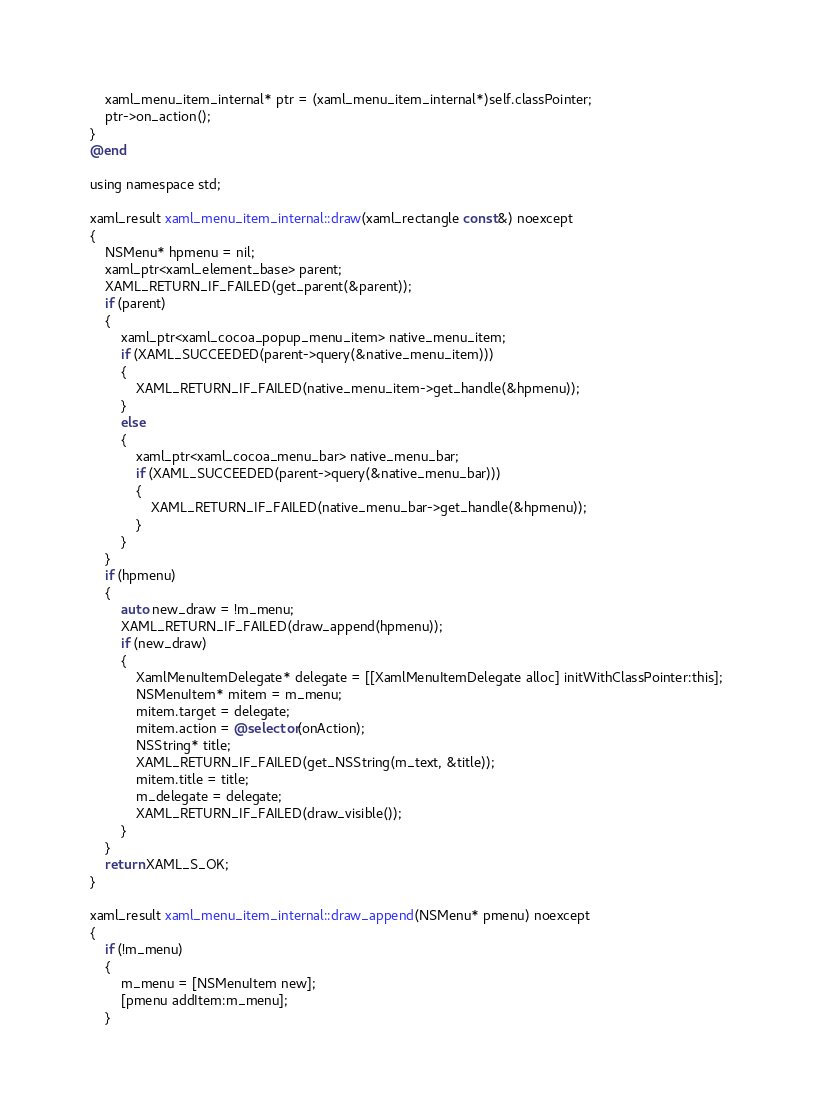Convert code to text. <code><loc_0><loc_0><loc_500><loc_500><_ObjectiveC_>    xaml_menu_item_internal* ptr = (xaml_menu_item_internal*)self.classPointer;
    ptr->on_action();
}
@end

using namespace std;

xaml_result xaml_menu_item_internal::draw(xaml_rectangle const&) noexcept
{
    NSMenu* hpmenu = nil;
    xaml_ptr<xaml_element_base> parent;
    XAML_RETURN_IF_FAILED(get_parent(&parent));
    if (parent)
    {
        xaml_ptr<xaml_cocoa_popup_menu_item> native_menu_item;
        if (XAML_SUCCEEDED(parent->query(&native_menu_item)))
        {
            XAML_RETURN_IF_FAILED(native_menu_item->get_handle(&hpmenu));
        }
        else
        {
            xaml_ptr<xaml_cocoa_menu_bar> native_menu_bar;
            if (XAML_SUCCEEDED(parent->query(&native_menu_bar)))
            {
                XAML_RETURN_IF_FAILED(native_menu_bar->get_handle(&hpmenu));
            }
        }
    }
    if (hpmenu)
    {
        auto new_draw = !m_menu;
        XAML_RETURN_IF_FAILED(draw_append(hpmenu));
        if (new_draw)
        {
            XamlMenuItemDelegate* delegate = [[XamlMenuItemDelegate alloc] initWithClassPointer:this];
            NSMenuItem* mitem = m_menu;
            mitem.target = delegate;
            mitem.action = @selector(onAction);
            NSString* title;
            XAML_RETURN_IF_FAILED(get_NSString(m_text, &title));
            mitem.title = title;
            m_delegate = delegate;
            XAML_RETURN_IF_FAILED(draw_visible());
        }
    }
    return XAML_S_OK;
}

xaml_result xaml_menu_item_internal::draw_append(NSMenu* pmenu) noexcept
{
    if (!m_menu)
    {
        m_menu = [NSMenuItem new];
        [pmenu addItem:m_menu];
    }</code> 